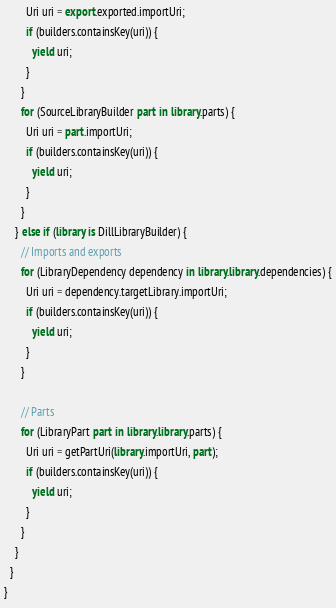<code> <loc_0><loc_0><loc_500><loc_500><_Dart_>        Uri uri = export.exported.importUri;
        if (builders.containsKey(uri)) {
          yield uri;
        }
      }
      for (SourceLibraryBuilder part in library.parts) {
        Uri uri = part.importUri;
        if (builders.containsKey(uri)) {
          yield uri;
        }
      }
    } else if (library is DillLibraryBuilder) {
      // Imports and exports
      for (LibraryDependency dependency in library.library.dependencies) {
        Uri uri = dependency.targetLibrary.importUri;
        if (builders.containsKey(uri)) {
          yield uri;
        }
      }

      // Parts
      for (LibraryPart part in library.library.parts) {
        Uri uri = getPartUri(library.importUri, part);
        if (builders.containsKey(uri)) {
          yield uri;
        }
      }
    }
  }
}
</code> 